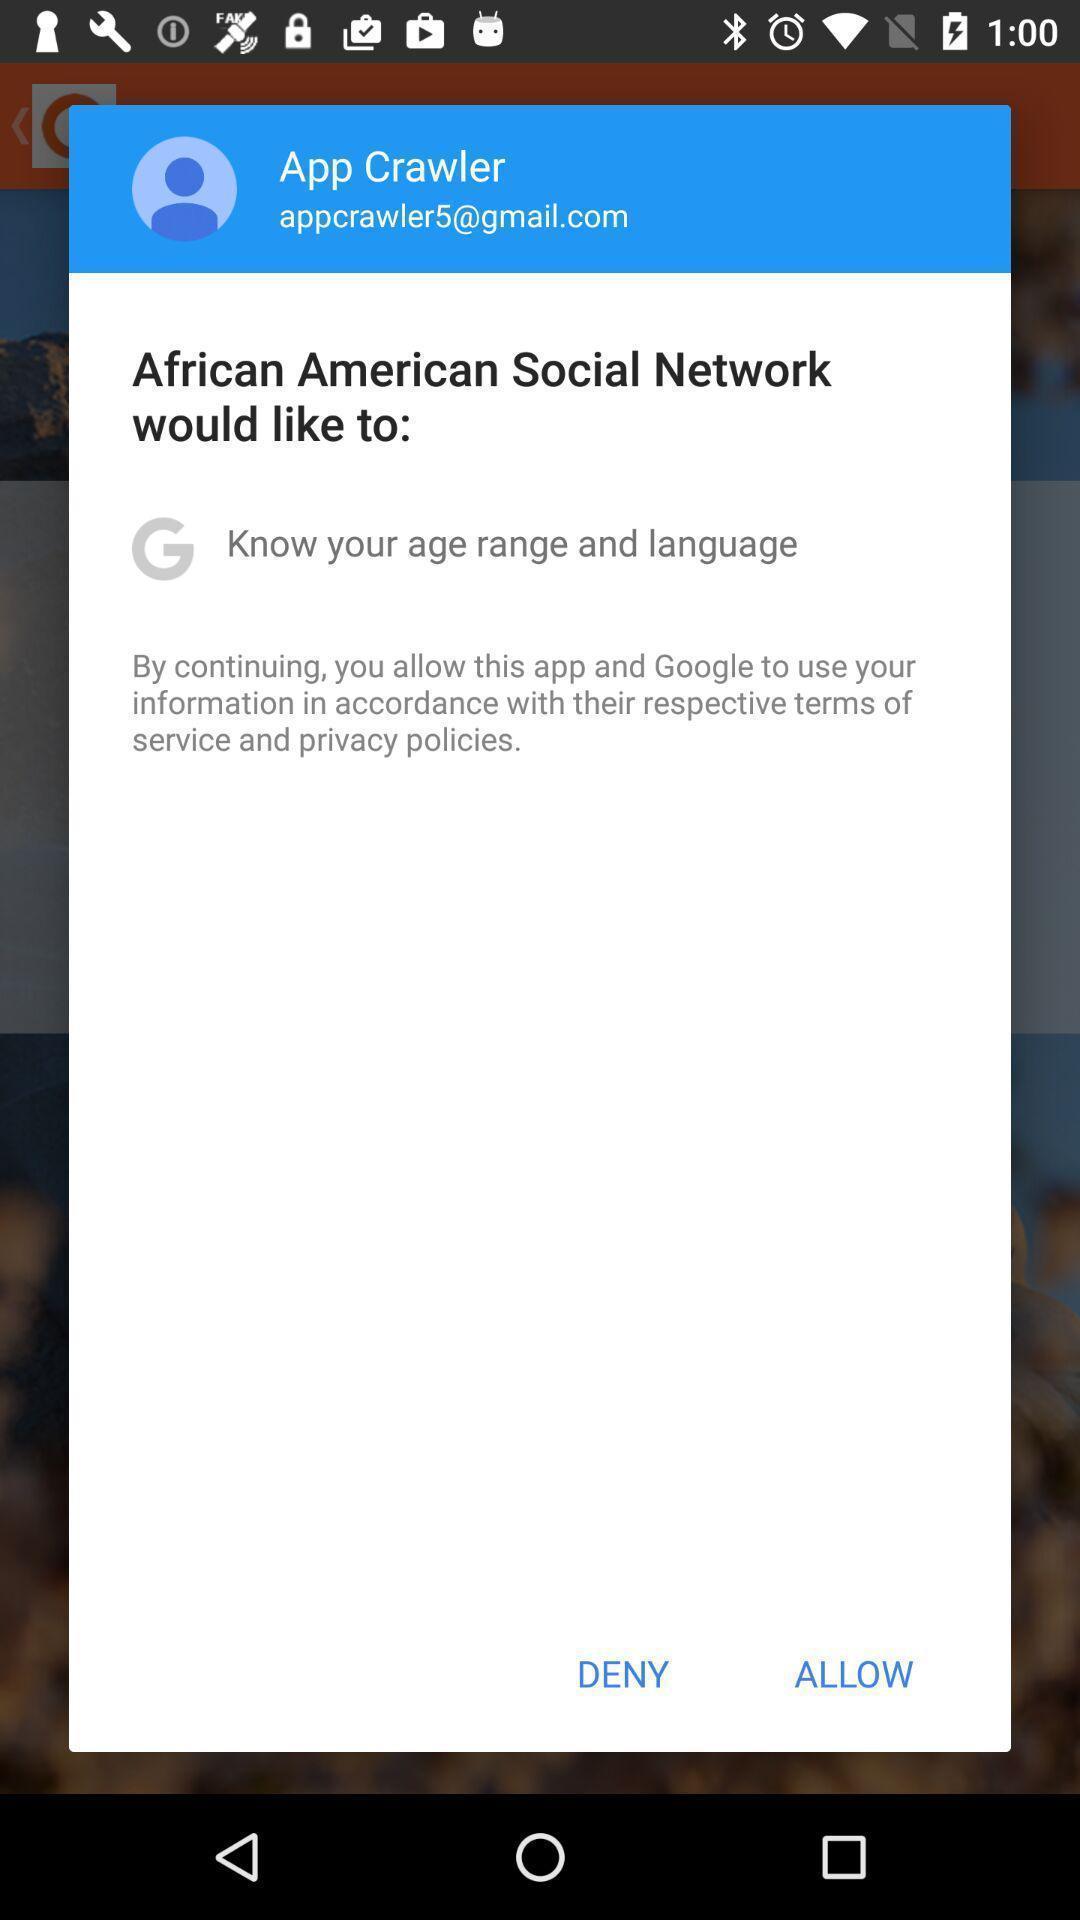What can you discern from this picture? Popup to give permission in the social network app. 